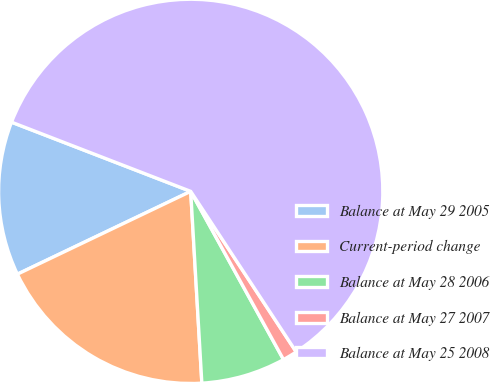Convert chart. <chart><loc_0><loc_0><loc_500><loc_500><pie_chart><fcel>Balance at May 29 2005<fcel>Current-period change<fcel>Balance at May 28 2006<fcel>Balance at May 27 2007<fcel>Balance at May 25 2008<nl><fcel>12.96%<fcel>18.83%<fcel>7.1%<fcel>1.23%<fcel>59.88%<nl></chart> 